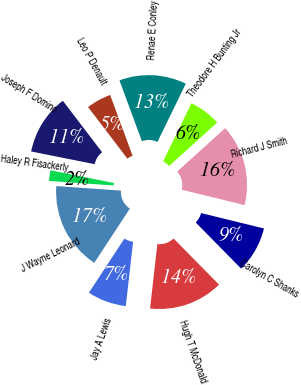<chart> <loc_0><loc_0><loc_500><loc_500><pie_chart><fcel>Theodore H Bunting Jr<fcel>Renae E Conley<fcel>Leo P Denault<fcel>Joseph F Domino<fcel>Haley R Fisackerly<fcel>J Wayne Leonard<fcel>Jay A Lewis<fcel>Hugh T McDonald<fcel>Carolyn C Shanks<fcel>Richard J Smith<nl><fcel>6.09%<fcel>12.83%<fcel>4.75%<fcel>11.49%<fcel>2.02%<fcel>16.88%<fcel>7.44%<fcel>14.18%<fcel>8.79%<fcel>15.53%<nl></chart> 